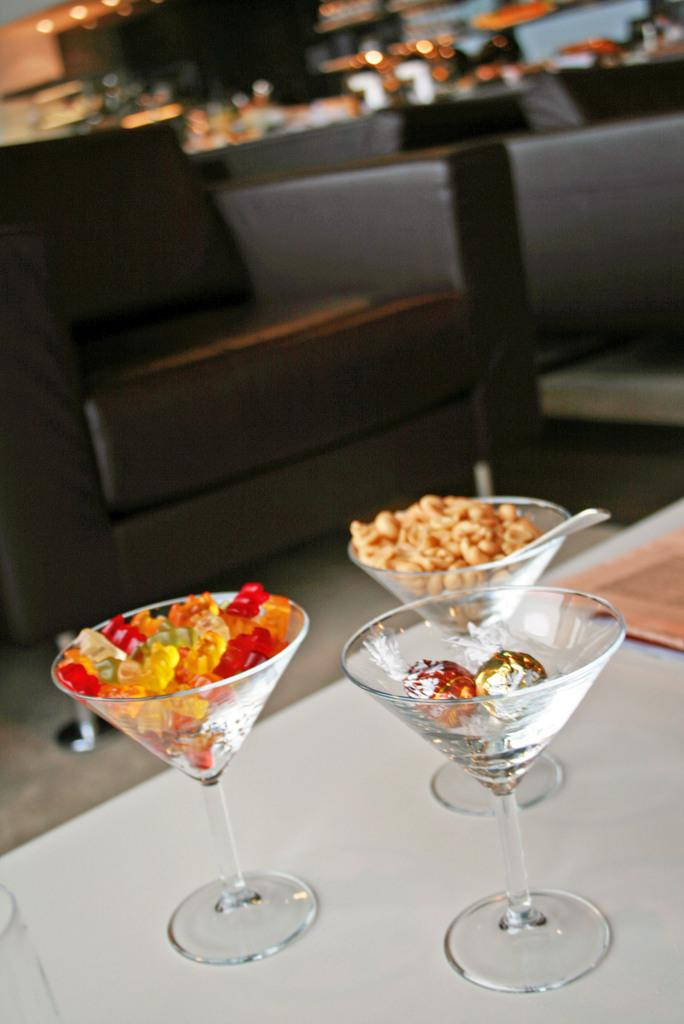What objects are on the table in the image? There are glasses on a table in the image. What is the color of the table? The table is white. What type of seating is visible in the image? There is a brown color sofa in the image. How would you describe the background of the image? The background of the image is blurred. What type of shirt is the person wearing in the image? There is no person visible in the image, so it is not possible to determine what type of shirt they might be wearing. 